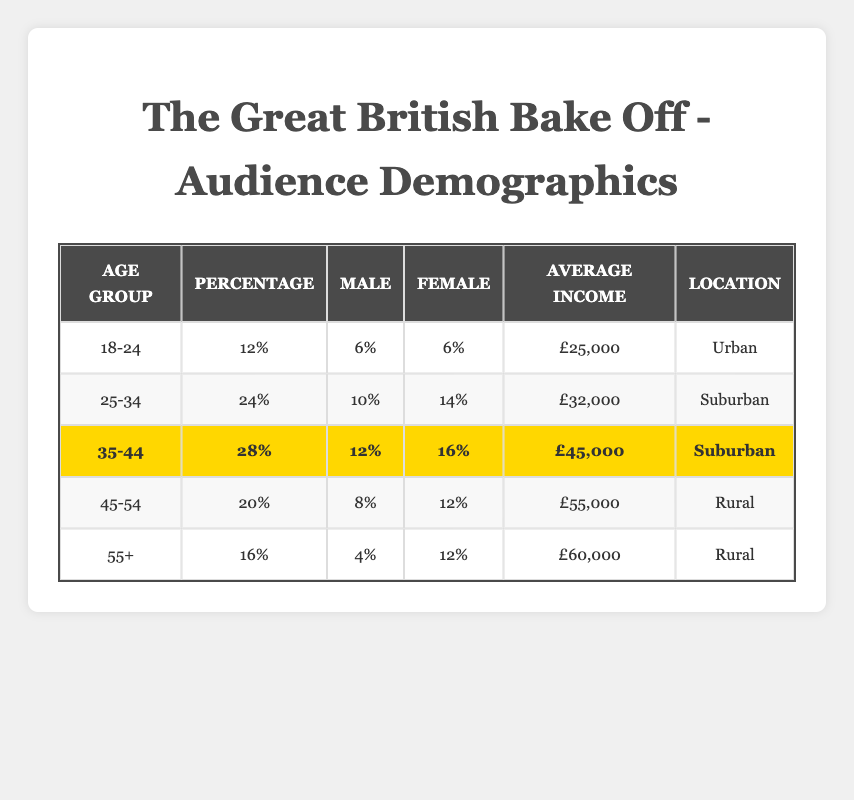What's the percentage of the 25-34 age group? The table states that the percentage for the 25-34 age group is listed directly in the corresponding row. It shows 24%.
Answer: 24% What is the average income of the 45-54 age group? The average income for the 45-54 age group is provided in the table under the 'Average Income' column. It is £55,000.
Answer: £55,000 How many females are there in the 18-24 age group? The table shows the gender distribution for the 18-24 age group, which indicates 6% female viewers.
Answer: 6% What is the total percentage of male viewers across all age groups? To find this, add up the male percentages from each age group: 6% + 10% + 12% + 8% + 4% = 40%.
Answer: 40% Is the average income higher for the 35-44 age group compared to the 25-34 age group? The average income for the 35-44 age group is £45,000, while for the 25-34 age group, it is £32,000. Since £45,000 is greater than £32,000, the statement is true.
Answer: Yes Which age group has the highest percentage of viewers? Looking through the table, the highest percentage is for the 35-44 age group, which has 28%.
Answer: 35-44 What is the difference in average income between the 55+ age group and the 25-34 age group? The average income for the 55+ age group is £60,000, and for the 25-34 age group, it is £32,000. The difference is £60,000 - £32,000 = £28,000.
Answer: £28,000 Which location has the most viewers based on the 35-44 age group? Both the 25-34 and 35-44 age groups are listed as Suburban, but since the 35-44 age group has the highest percentage (28%), Suburban is confirmed as having the most viewers.
Answer: Suburban Are there more female viewers than male viewers in the 55+ age group? The table shows that in the 55+ age group, there are 12% female and 4% male viewers. Since 12% is greater than 4%, there are indeed more female viewers.
Answer: Yes What percentage of viewers are aged 45 or older? To find this, add the percentages of the 45-54 age group (20%) and the 55+ age group (16%): 20% + 16% = 36%.
Answer: 36% 